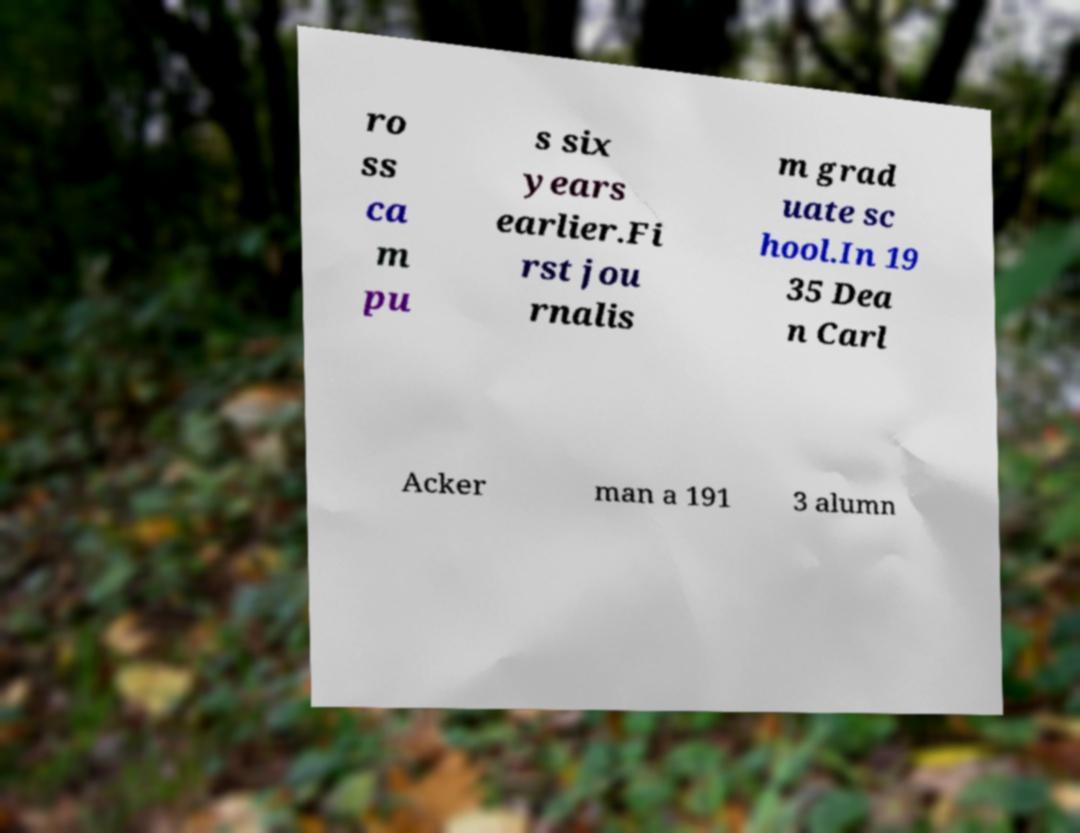Can you accurately transcribe the text from the provided image for me? ro ss ca m pu s six years earlier.Fi rst jou rnalis m grad uate sc hool.In 19 35 Dea n Carl Acker man a 191 3 alumn 